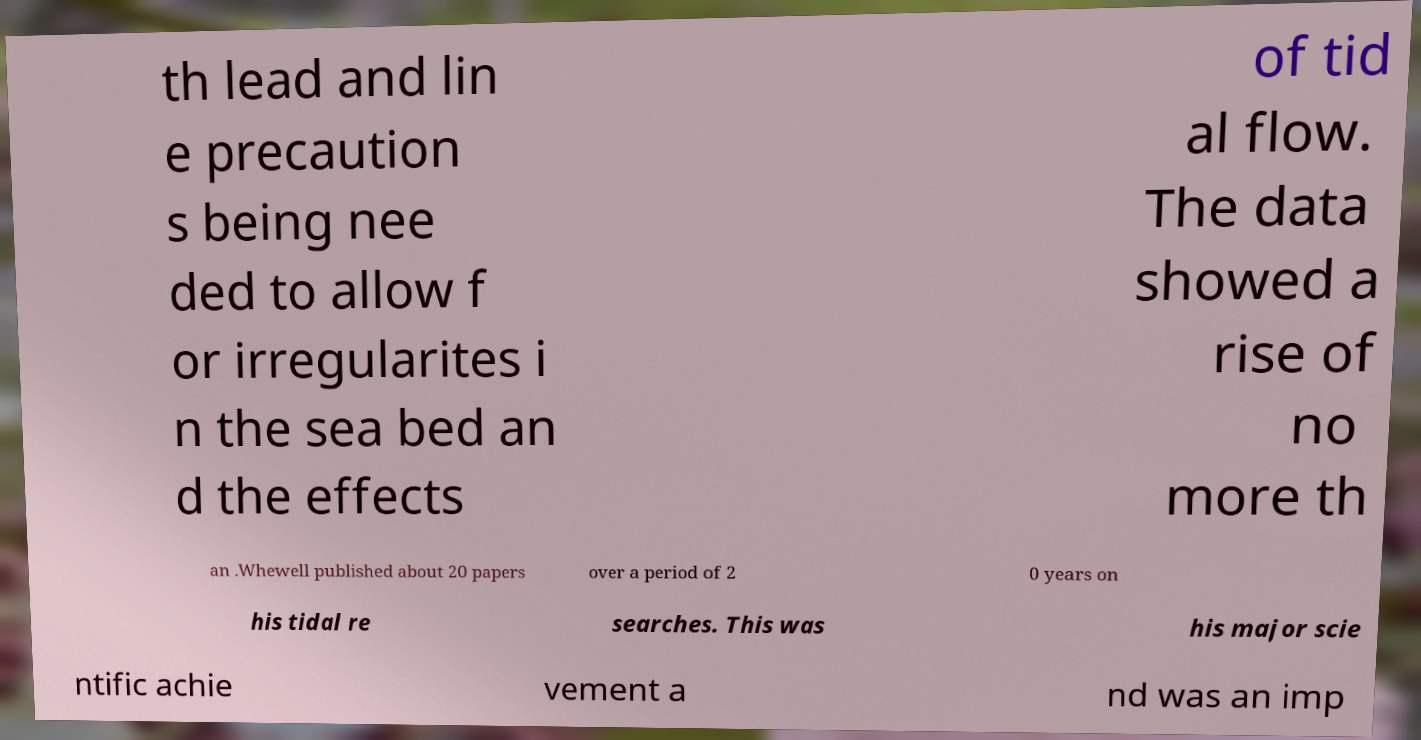For documentation purposes, I need the text within this image transcribed. Could you provide that? th lead and lin e precaution s being nee ded to allow f or irregularites i n the sea bed an d the effects of tid al flow. The data showed a rise of no more th an .Whewell published about 20 papers over a period of 2 0 years on his tidal re searches. This was his major scie ntific achie vement a nd was an imp 